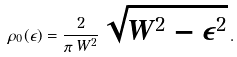Convert formula to latex. <formula><loc_0><loc_0><loc_500><loc_500>\rho _ { 0 } ( \epsilon ) = \frac { 2 } { \pi \, W ^ { 2 } } \, \sqrt { W ^ { 2 } - \epsilon ^ { 2 } } \, .</formula> 